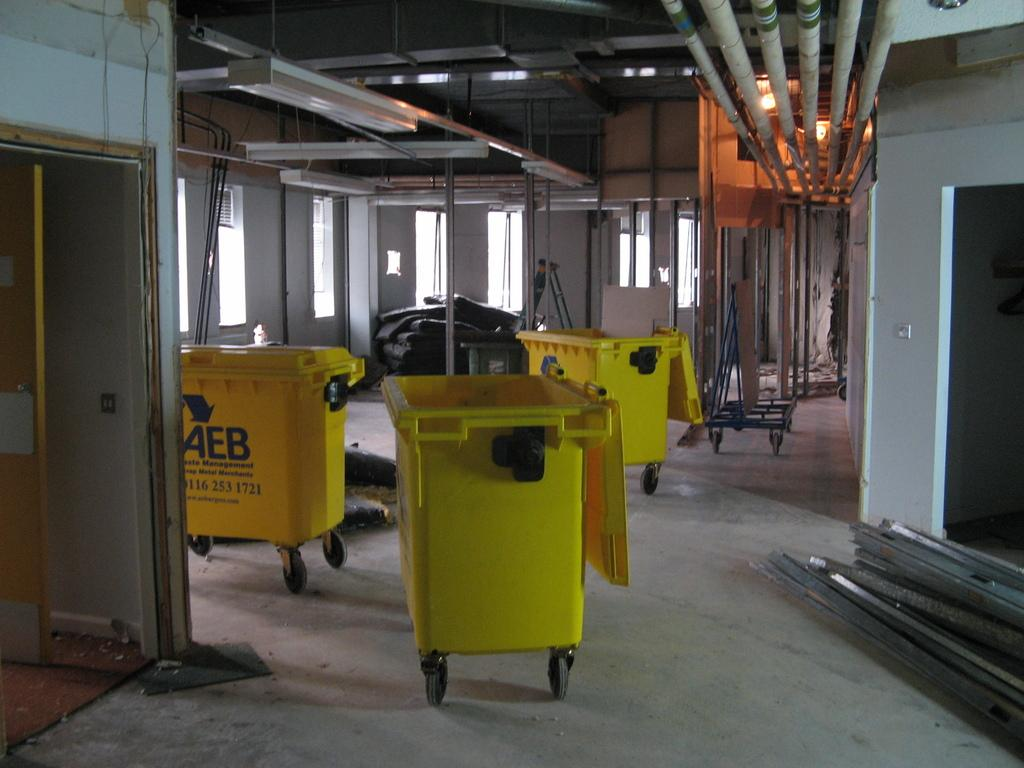<image>
Write a terse but informative summary of the picture. AEB are the letters on the yellow item 